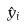Convert formula to latex. <formula><loc_0><loc_0><loc_500><loc_500>\hat { y } _ { i }</formula> 